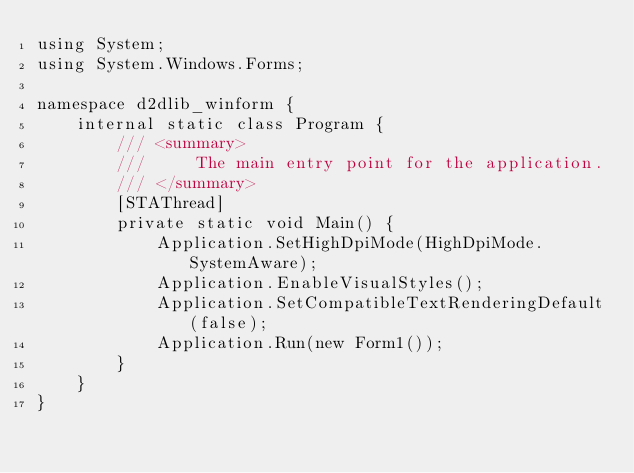Convert code to text. <code><loc_0><loc_0><loc_500><loc_500><_C#_>using System;
using System.Windows.Forms;

namespace d2dlib_winform {
    internal static class Program {
        /// <summary>
        ///     The main entry point for the application.
        /// </summary>
        [STAThread]
        private static void Main() {
            Application.SetHighDpiMode(HighDpiMode.SystemAware);
            Application.EnableVisualStyles();
            Application.SetCompatibleTextRenderingDefault(false);
            Application.Run(new Form1());
        }
    }
}</code> 